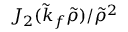Convert formula to latex. <formula><loc_0><loc_0><loc_500><loc_500>J _ { 2 } ( \tilde { k } _ { f } \tilde { \rho } ) / \tilde { \rho } ^ { 2 }</formula> 